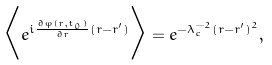Convert formula to latex. <formula><loc_0><loc_0><loc_500><loc_500>\Big < e ^ { i \frac { \partial \varphi ( { r } , t _ { 0 } ) } { \partial { r } } ( { r - r ^ { \prime } } ) } \Big > = e ^ { - \lambda _ { c } ^ { - 2 } ( { r - r ^ { \prime } } ) ^ { 2 } } ,</formula> 